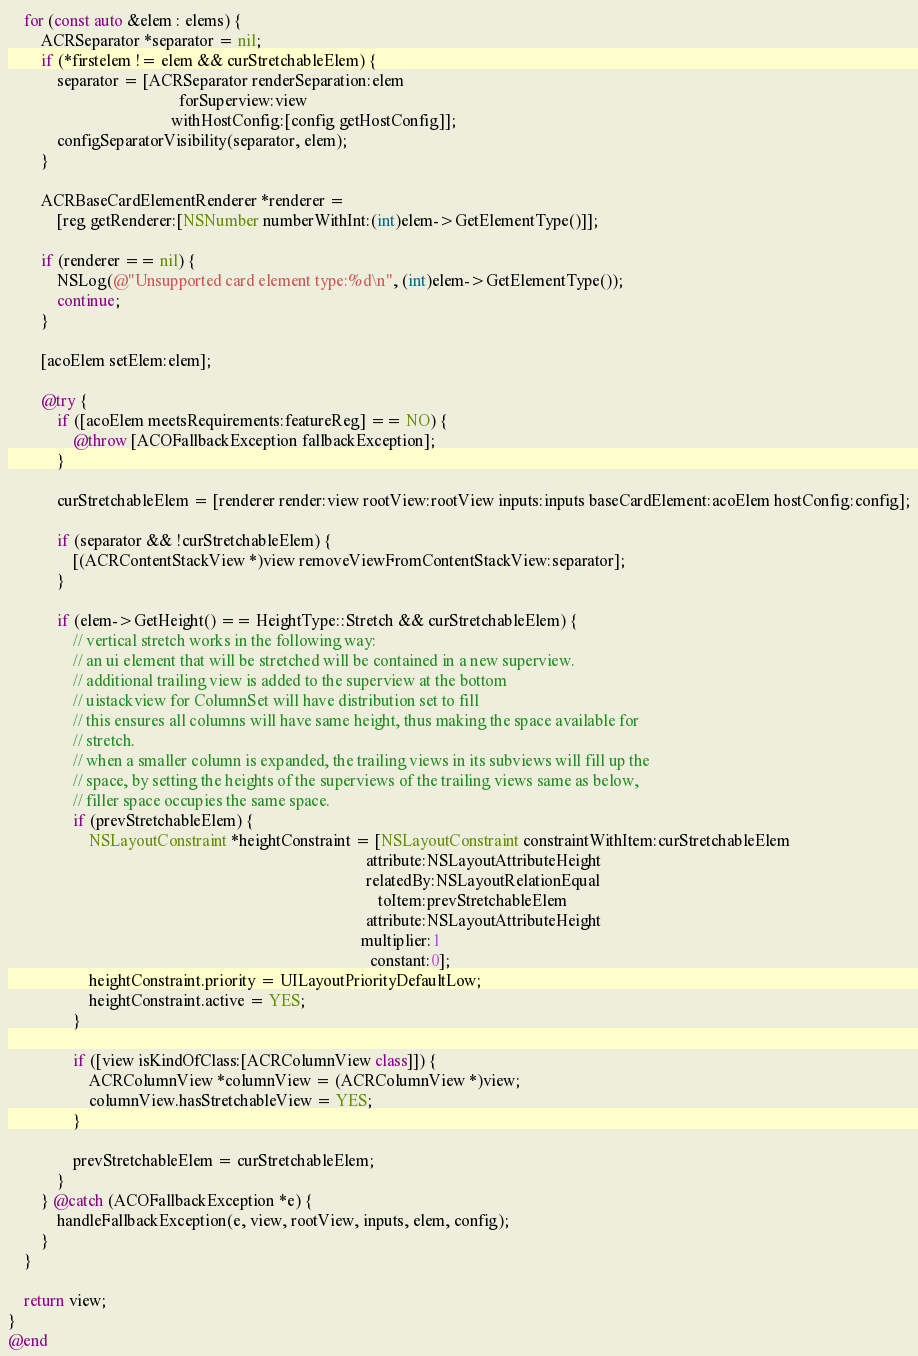<code> <loc_0><loc_0><loc_500><loc_500><_ObjectiveC_>    for (const auto &elem : elems) {
        ACRSeparator *separator = nil;
        if (*firstelem != elem && curStretchableElem) {
            separator = [ACRSeparator renderSeparation:elem
                                          forSuperview:view
                                        withHostConfig:[config getHostConfig]];
            configSeparatorVisibility(separator, elem);
        }

        ACRBaseCardElementRenderer *renderer =
            [reg getRenderer:[NSNumber numberWithInt:(int)elem->GetElementType()]];

        if (renderer == nil) {
            NSLog(@"Unsupported card element type:%d\n", (int)elem->GetElementType());
            continue;
        }

        [acoElem setElem:elem];

        @try {
            if ([acoElem meetsRequirements:featureReg] == NO) {
                @throw [ACOFallbackException fallbackException];
            }

            curStretchableElem = [renderer render:view rootView:rootView inputs:inputs baseCardElement:acoElem hostConfig:config];

            if (separator && !curStretchableElem) {
                [(ACRContentStackView *)view removeViewFromContentStackView:separator];
            }

            if (elem->GetHeight() == HeightType::Stretch && curStretchableElem) {
                // vertical stretch works in the following way:
                // an ui element that will be stretched will be contained in a new superview.
                // additional trailing view is added to the superview at the bottom
                // uistackview for ColumnSet will have distribution set to fill
                // this ensures all columns will have same height, thus making the space available for
                // stretch.
                // when a smaller column is expanded, the trailing views in its subviews will fill up the
                // space, by setting the heights of the superviews of the trailing views same as below,
                // filler space occupies the same space.
                if (prevStretchableElem) {
                    NSLayoutConstraint *heightConstraint = [NSLayoutConstraint constraintWithItem:curStretchableElem
                                                                                        attribute:NSLayoutAttributeHeight
                                                                                        relatedBy:NSLayoutRelationEqual
                                                                                           toItem:prevStretchableElem
                                                                                        attribute:NSLayoutAttributeHeight
                                                                                       multiplier:1
                                                                                         constant:0];
                    heightConstraint.priority = UILayoutPriorityDefaultLow;
                    heightConstraint.active = YES;
                }

                if ([view isKindOfClass:[ACRColumnView class]]) {
                    ACRColumnView *columnView = (ACRColumnView *)view;
                    columnView.hasStretchableView = YES;
                }

                prevStretchableElem = curStretchableElem;
            }
        } @catch (ACOFallbackException *e) {
            handleFallbackException(e, view, rootView, inputs, elem, config);
        }
    }

    return view;
}
@end
</code> 